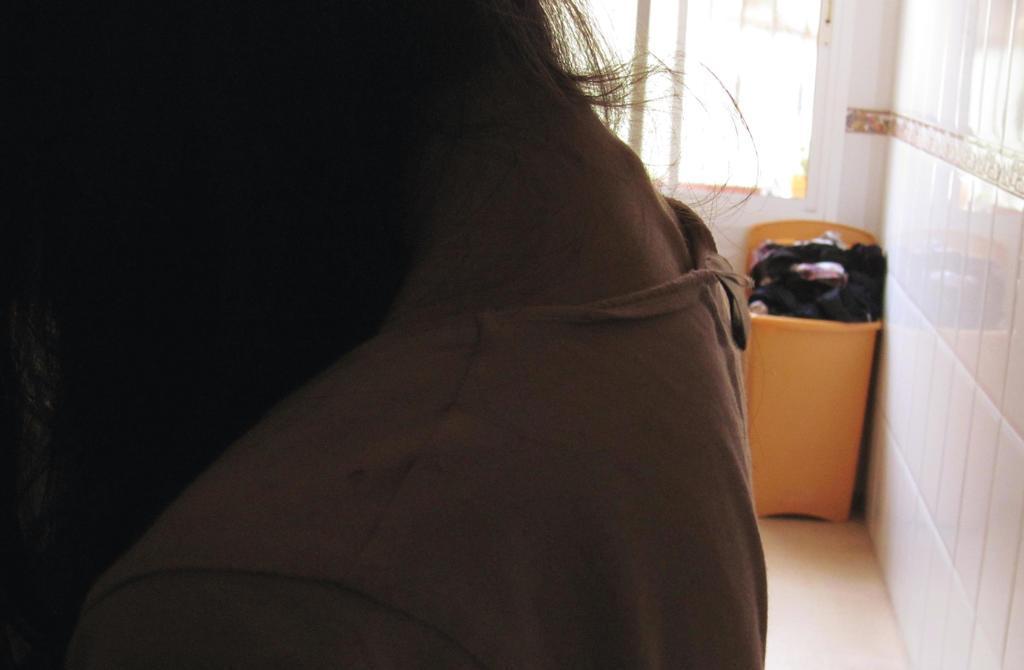How would you summarize this image in a sentence or two? In this image we can see the neck of a woman. On the right side we can see a wall, a dustbin, floor and a window. 